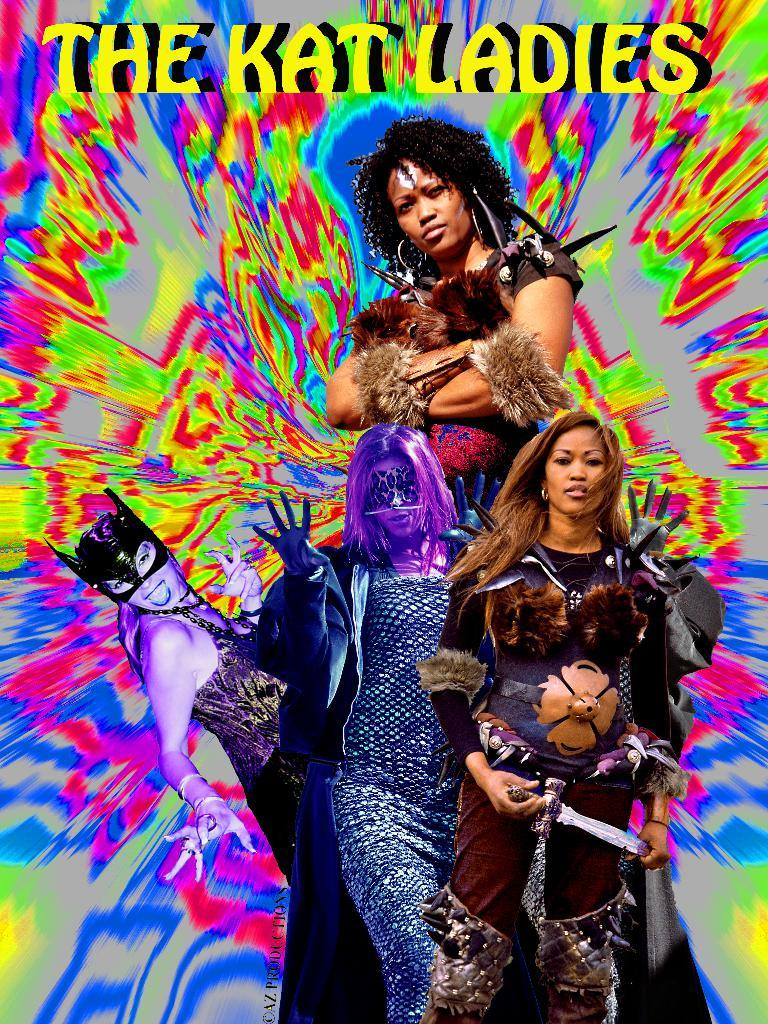Who or what can be seen in the image? There are people in the image. What is written or displayed at the top of the image? There is text at the top of the image. Can you describe the background of the image? The background of the image is multicolored. Are there any curtains visible in the image? There is no mention of curtains in the provided facts, so we cannot determine if they are present in the image. 